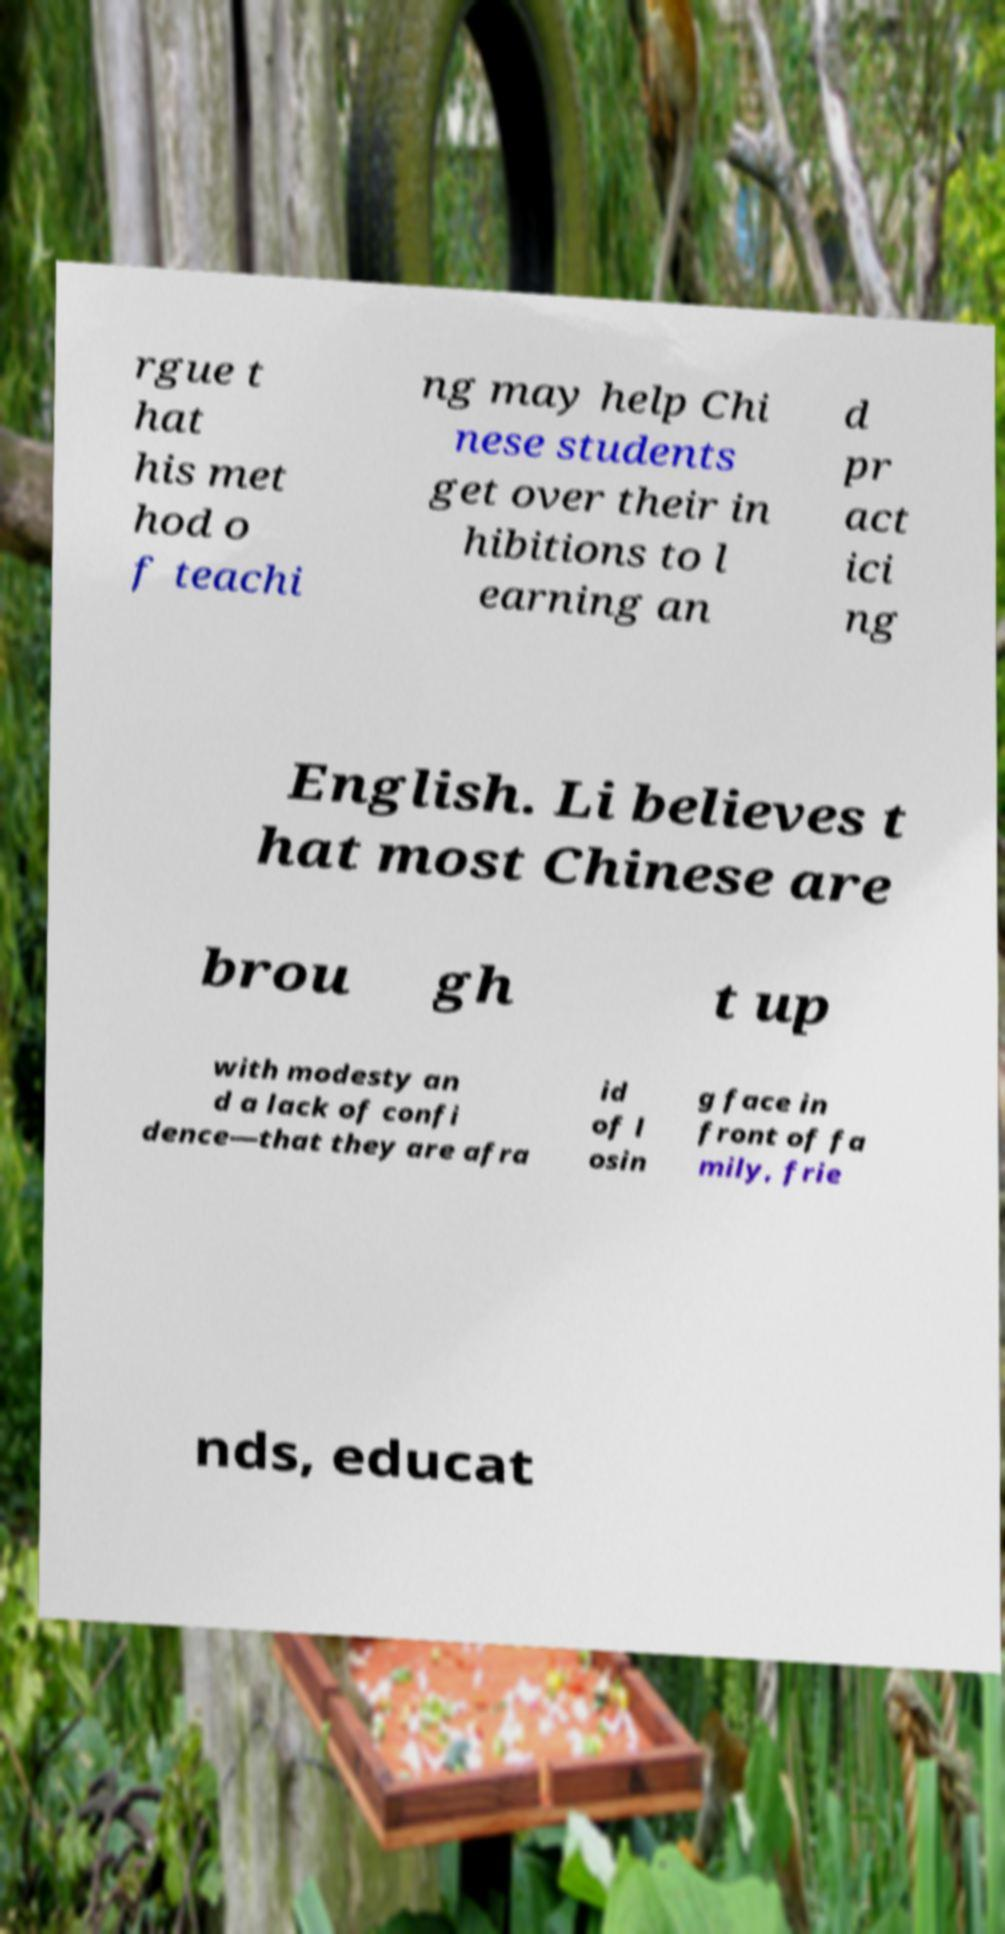Can you accurately transcribe the text from the provided image for me? rgue t hat his met hod o f teachi ng may help Chi nese students get over their in hibitions to l earning an d pr act ici ng English. Li believes t hat most Chinese are brou gh t up with modesty an d a lack of confi dence—that they are afra id of l osin g face in front of fa mily, frie nds, educat 